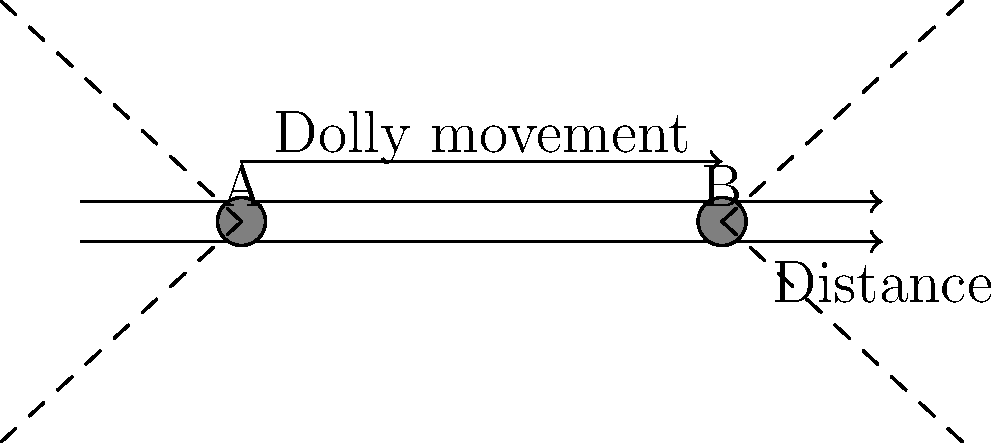In a dolly shot moving from point A to point B as shown in the diagram, how does the apparent size and perspective of objects in the foreground change compared to objects in the background? What physical principle explains this effect? To understand the effect of a dolly shot on viewer perception, we need to consider the following steps:

1. Dolly movement: The camera moves along a track from point A to point B, maintaining a constant height and angle.

2. Relative distance changes:
   a) Foreground objects: The distance between the camera and foreground objects changes significantly.
   b) Background objects: The distance between the camera and background objects changes much less in proportion.

3. Angular size changes:
   a) Foreground objects: Their angular size in the frame changes noticeably as the camera moves.
   b) Background objects: Their angular size remains relatively constant.

4. Perspective shift:
   The changing relationship between foreground and background objects creates a dynamic perspective shift.

5. Physical principle: This effect is explained by the inverse square law of distance. The apparent size of an object is inversely proportional to the square of its distance from the observer.

   Mathematically: $\text{Apparent Size} \propto \frac{1}{\text{Distance}^2}$

6. Perceptual impact:
   a) Foreground objects appear to move more quickly across the frame.
   b) Background objects appear relatively stationary.
   c) This creates a sense of depth and three-dimensionality in the shot.

7. Cinematic term: This effect is known as "parallax" in filmmaking, which enhances the sense of movement and depth in a scene.
Answer: Foreground objects change size/position more dramatically than background objects due to the inverse square law, creating parallax and enhancing depth perception. 